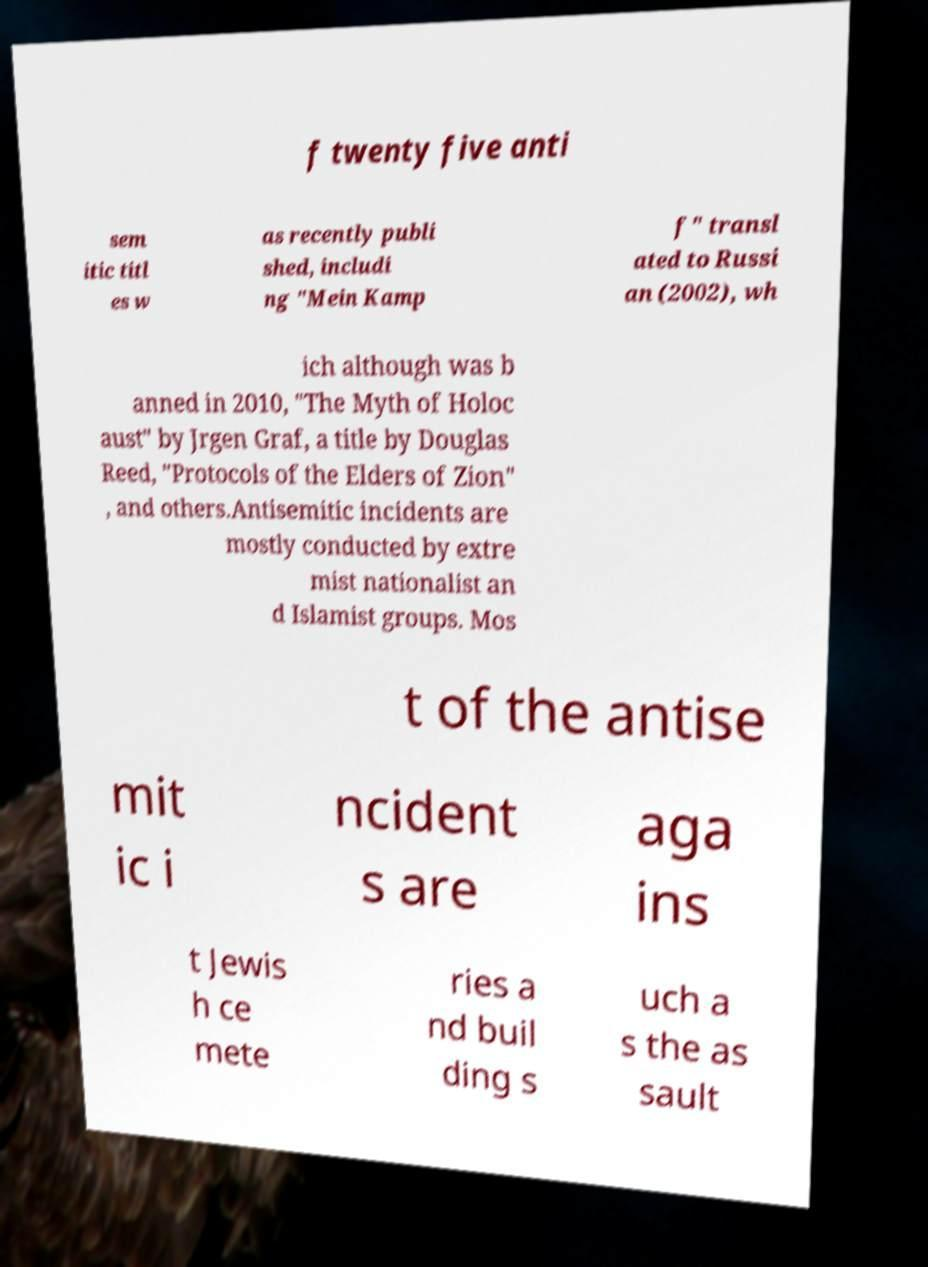Could you assist in decoding the text presented in this image and type it out clearly? f twenty five anti sem itic titl es w as recently publi shed, includi ng "Mein Kamp f" transl ated to Russi an (2002), wh ich although was b anned in 2010, "The Myth of Holoc aust" by Jrgen Graf, a title by Douglas Reed, "Protocols of the Elders of Zion" , and others.Antisemitic incidents are mostly conducted by extre mist nationalist an d Islamist groups. Mos t of the antise mit ic i ncident s are aga ins t Jewis h ce mete ries a nd buil ding s uch a s the as sault 